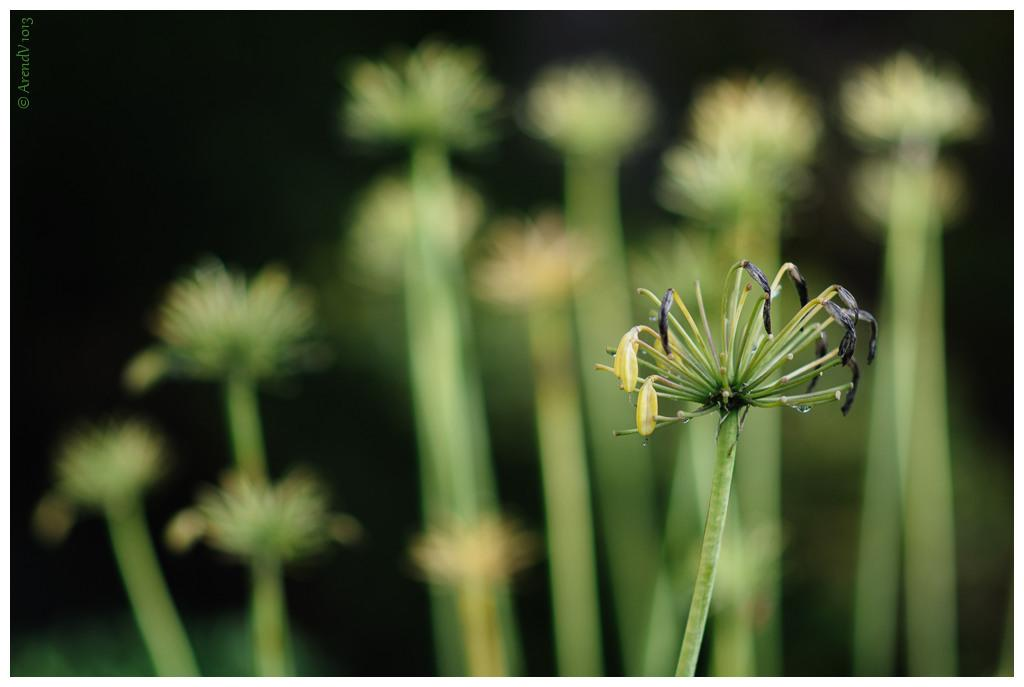What is the main subject of the picture? There is a flower in the picture. Can you describe the background of the image? The background of the image is blurred, and there are flowers in the background. What type of oatmeal can be seen in the picture? There is no oatmeal present in the picture; it features a flower and a blurred background with additional flowers. 